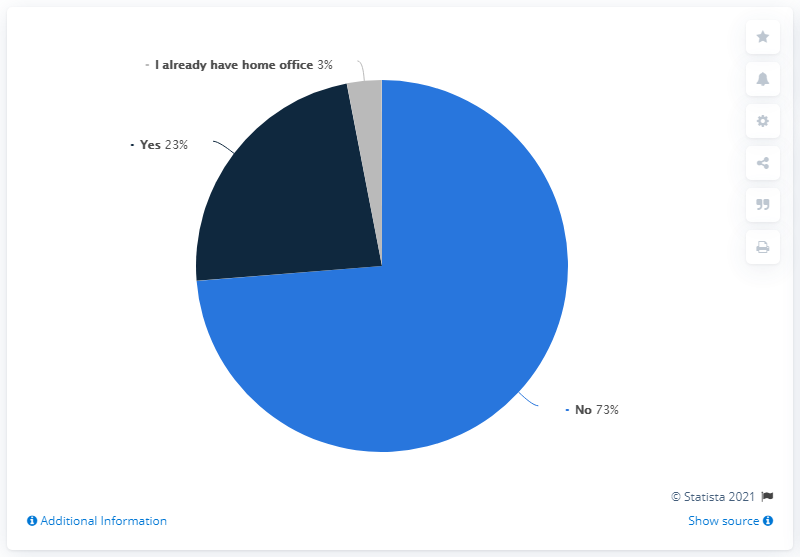Point out several critical features in this image. The median opinion minus the minimum opinion is equal to 20. I would like to rank the sizes of the segments in order from largest to smallest, with colors starting from blue, then navy blue, and finally gray. 